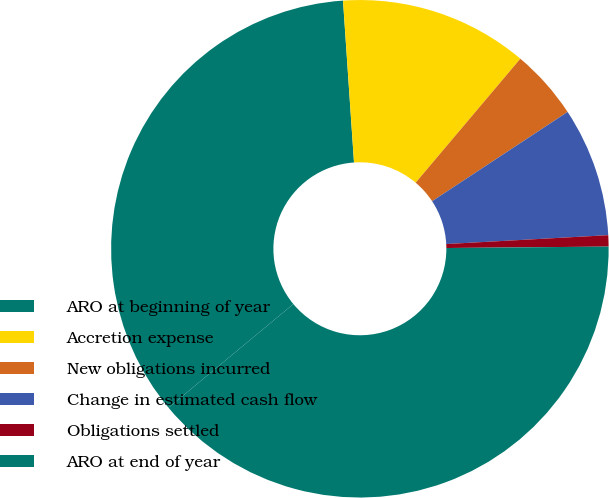Convert chart. <chart><loc_0><loc_0><loc_500><loc_500><pie_chart><fcel>ARO at beginning of year<fcel>Accretion expense<fcel>New obligations incurred<fcel>Change in estimated cash flow<fcel>Obligations settled<fcel>ARO at end of year<nl><fcel>34.95%<fcel>12.24%<fcel>4.57%<fcel>8.4%<fcel>0.73%<fcel>39.11%<nl></chart> 